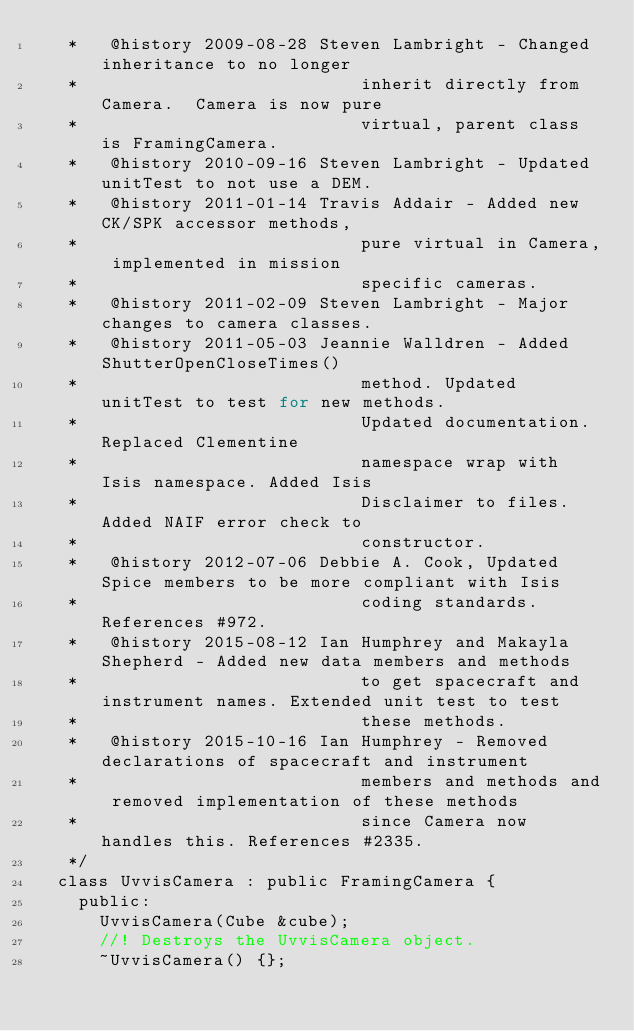<code> <loc_0><loc_0><loc_500><loc_500><_C_>   *   @history 2009-08-28 Steven Lambright - Changed inheritance to no longer
   *                           inherit directly from Camera.  Camera is now pure
   *                           virtual, parent class is FramingCamera.
   *   @history 2010-09-16 Steven Lambright - Updated unitTest to not use a DEM.
   *   @history 2011-01-14 Travis Addair - Added new CK/SPK accessor methods,
   *                           pure virtual in Camera, implemented in mission
   *                           specific cameras.
   *   @history 2011-02-09 Steven Lambright - Major changes to camera classes.
   *   @history 2011-05-03 Jeannie Walldren - Added ShutterOpenCloseTimes()
   *                           method. Updated unitTest to test for new methods.
   *                           Updated documentation. Replaced Clementine
   *                           namespace wrap with Isis namespace. Added Isis
   *                           Disclaimer to files. Added NAIF error check to
   *                           constructor.
   *   @history 2012-07-06 Debbie A. Cook, Updated Spice members to be more compliant with Isis 
   *                           coding standards. References #972.
   *   @history 2015-08-12 Ian Humphrey and Makayla Shepherd - Added new data members and methods
   *                           to get spacecraft and instrument names. Extended unit test to test
   *                           these methods.
   *   @history 2015-10-16 Ian Humphrey - Removed declarations of spacecraft and instrument 
   *                           members and methods and removed implementation of these methods
   *                           since Camera now handles this. References #2335.
   */
  class UvvisCamera : public FramingCamera {
    public:
      UvvisCamera(Cube &cube);
      //! Destroys the UvvisCamera object.
      ~UvvisCamera() {};</code> 